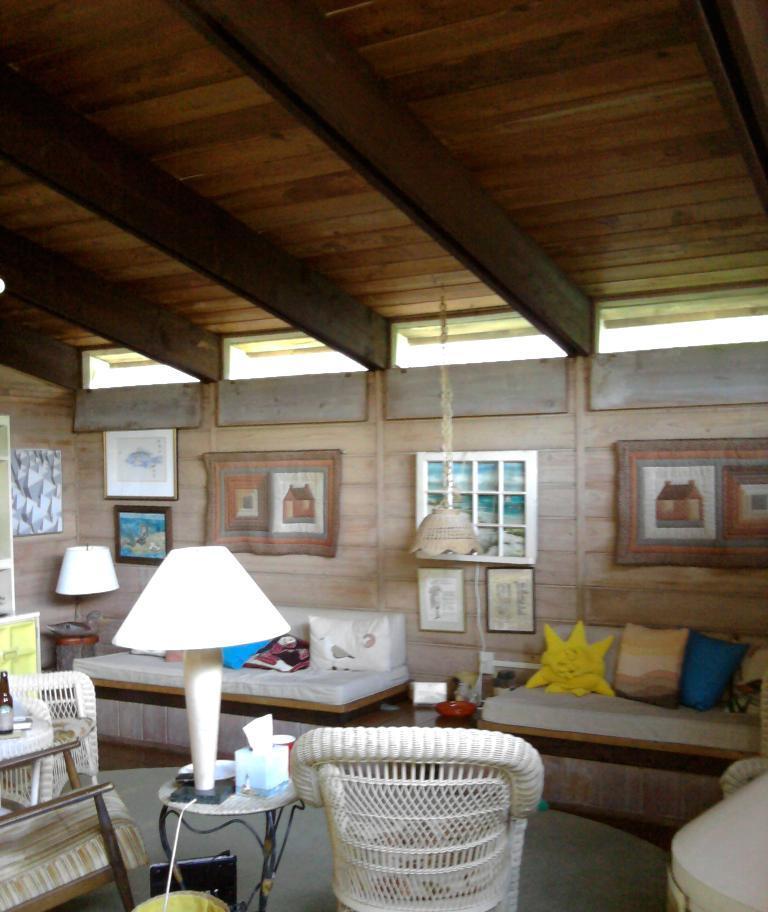In one or two sentences, can you explain what this image depicts? in this image i can see a room. there is a chair in the center. at the right there is a stool which has a lamp on it and it the left there is another table which has a glass bottle on it. behind that there is a bed which has cushions on it. behind that there is wall and photo-frames. another lamp is hanging on the roof 